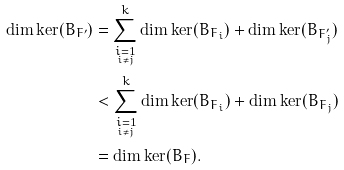<formula> <loc_0><loc_0><loc_500><loc_500>\dim \ker ( B _ { F ^ { \prime } } ) & = \sum _ { \underset { i \neq j } { i = 1 } } ^ { k } \dim \ker ( B _ { F _ { i } } ) + \dim \ker ( B _ { F _ { j } ^ { \prime } } ) \\ & < \sum _ { \underset { i \neq j } { i = 1 } } ^ { k } \dim \ker ( B _ { F _ { i } } ) + \dim \ker ( B _ { F _ { j } } ) \\ & = \dim \ker ( B _ { F } ) .</formula> 